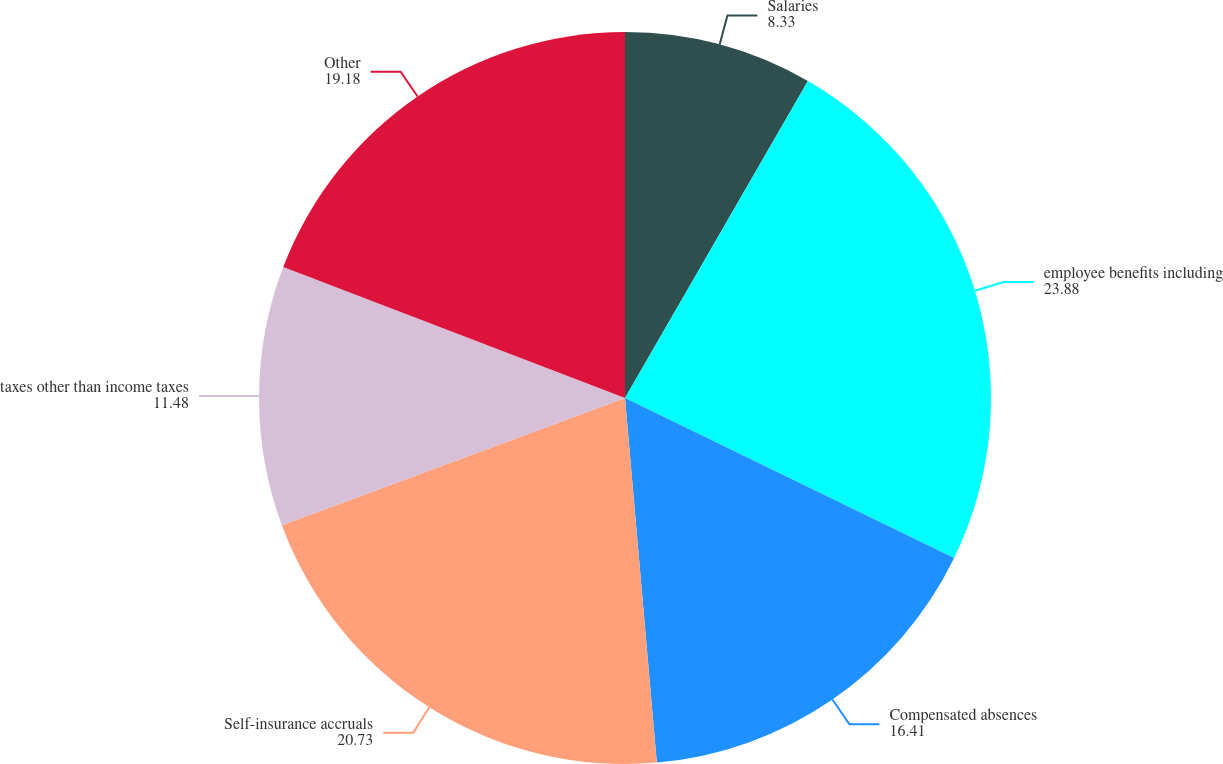Convert chart to OTSL. <chart><loc_0><loc_0><loc_500><loc_500><pie_chart><fcel>Salaries<fcel>employee benefits including<fcel>Compensated absences<fcel>Self-insurance accruals<fcel>taxes other than income taxes<fcel>Other<nl><fcel>8.33%<fcel>23.88%<fcel>16.41%<fcel>20.73%<fcel>11.48%<fcel>19.18%<nl></chart> 